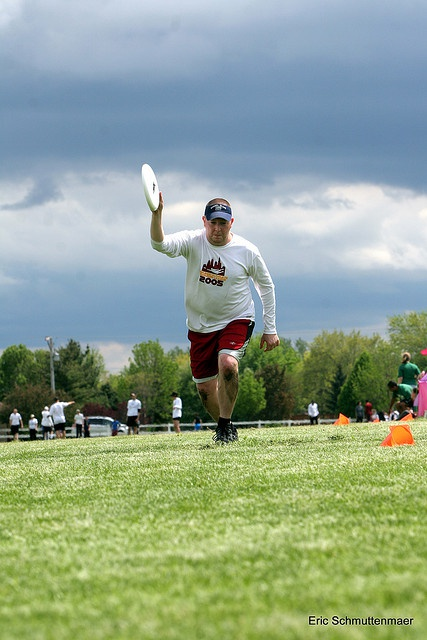Describe the objects in this image and their specific colors. I can see people in lightgray, darkgray, black, and olive tones, frisbee in lightgray, white, darkgray, and olive tones, people in lightgray, black, darkgreen, gray, and teal tones, car in lightgray, darkgray, black, and gray tones, and people in lightgray, black, darkgray, and gray tones in this image. 